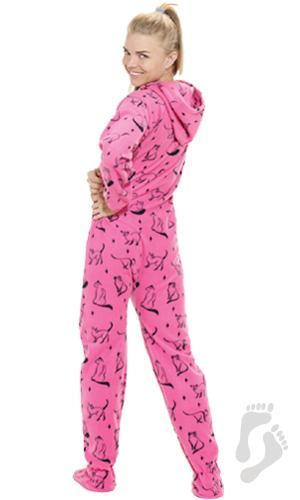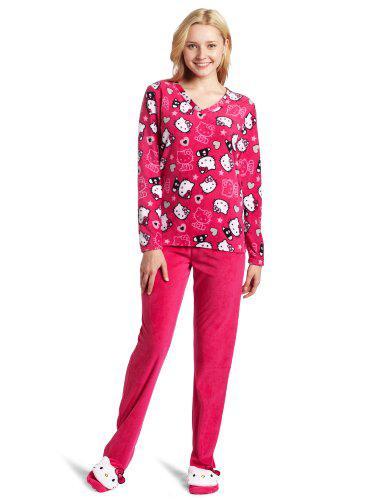The first image is the image on the left, the second image is the image on the right. For the images shown, is this caption "There are two female wearing pajamas by themselves" true? Answer yes or no. Yes. The first image is the image on the left, the second image is the image on the right. Analyze the images presented: Is the assertion "There is at least one person with their hood up." valid? Answer yes or no. No. 